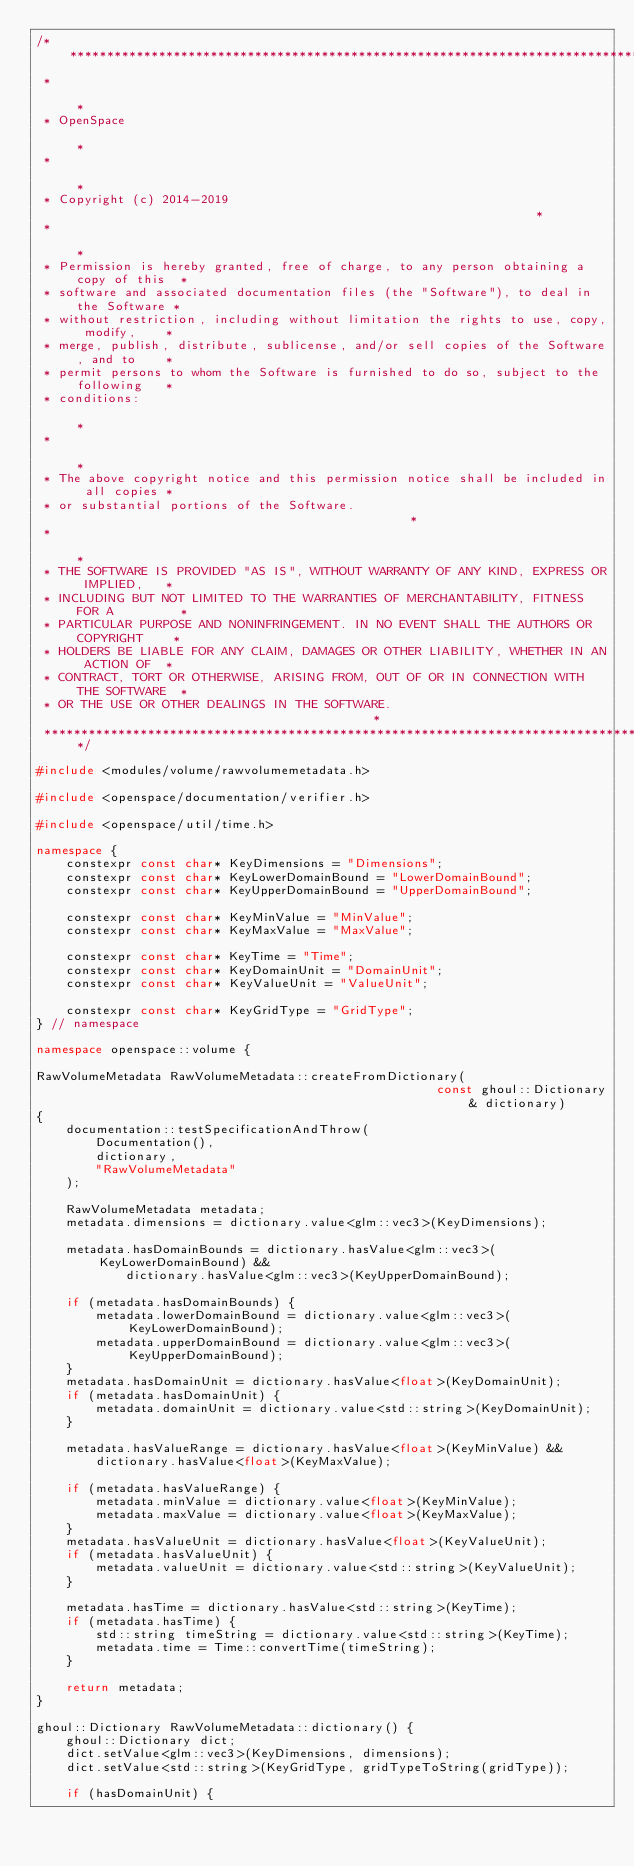Convert code to text. <code><loc_0><loc_0><loc_500><loc_500><_C++_>/*****************************************************************************************
 *                                                                                       *
 * OpenSpace                                                                             *
 *                                                                                       *
 * Copyright (c) 2014-2019                                                               *
 *                                                                                       *
 * Permission is hereby granted, free of charge, to any person obtaining a copy of this  *
 * software and associated documentation files (the "Software"), to deal in the Software *
 * without restriction, including without limitation the rights to use, copy, modify,    *
 * merge, publish, distribute, sublicense, and/or sell copies of the Software, and to    *
 * permit persons to whom the Software is furnished to do so, subject to the following   *
 * conditions:                                                                           *
 *                                                                                       *
 * The above copyright notice and this permission notice shall be included in all copies *
 * or substantial portions of the Software.                                              *
 *                                                                                       *
 * THE SOFTWARE IS PROVIDED "AS IS", WITHOUT WARRANTY OF ANY KIND, EXPRESS OR IMPLIED,   *
 * INCLUDING BUT NOT LIMITED TO THE WARRANTIES OF MERCHANTABILITY, FITNESS FOR A         *
 * PARTICULAR PURPOSE AND NONINFRINGEMENT. IN NO EVENT SHALL THE AUTHORS OR COPYRIGHT    *
 * HOLDERS BE LIABLE FOR ANY CLAIM, DAMAGES OR OTHER LIABILITY, WHETHER IN AN ACTION OF  *
 * CONTRACT, TORT OR OTHERWISE, ARISING FROM, OUT OF OR IN CONNECTION WITH THE SOFTWARE  *
 * OR THE USE OR OTHER DEALINGS IN THE SOFTWARE.                                         *
 ****************************************************************************************/

#include <modules/volume/rawvolumemetadata.h>

#include <openspace/documentation/verifier.h>

#include <openspace/util/time.h>

namespace {
    constexpr const char* KeyDimensions = "Dimensions";
    constexpr const char* KeyLowerDomainBound = "LowerDomainBound";
    constexpr const char* KeyUpperDomainBound = "UpperDomainBound";

    constexpr const char* KeyMinValue = "MinValue";
    constexpr const char* KeyMaxValue = "MaxValue";

    constexpr const char* KeyTime = "Time";
    constexpr const char* KeyDomainUnit = "DomainUnit";
    constexpr const char* KeyValueUnit = "ValueUnit";

    constexpr const char* KeyGridType = "GridType";
} // namespace

namespace openspace::volume {

RawVolumeMetadata RawVolumeMetadata::createFromDictionary(
                                                      const ghoul::Dictionary& dictionary)
{
    documentation::testSpecificationAndThrow(
        Documentation(),
        dictionary,
        "RawVolumeMetadata"
    );

    RawVolumeMetadata metadata;
    metadata.dimensions = dictionary.value<glm::vec3>(KeyDimensions);

    metadata.hasDomainBounds = dictionary.hasValue<glm::vec3>(KeyLowerDomainBound) &&
            dictionary.hasValue<glm::vec3>(KeyUpperDomainBound);

    if (metadata.hasDomainBounds) {
        metadata.lowerDomainBound = dictionary.value<glm::vec3>(KeyLowerDomainBound);
        metadata.upperDomainBound = dictionary.value<glm::vec3>(KeyUpperDomainBound);
    }
    metadata.hasDomainUnit = dictionary.hasValue<float>(KeyDomainUnit);
    if (metadata.hasDomainUnit) {
        metadata.domainUnit = dictionary.value<std::string>(KeyDomainUnit);
    }

    metadata.hasValueRange = dictionary.hasValue<float>(KeyMinValue) &&
        dictionary.hasValue<float>(KeyMaxValue);

    if (metadata.hasValueRange) {
        metadata.minValue = dictionary.value<float>(KeyMinValue);
        metadata.maxValue = dictionary.value<float>(KeyMaxValue);
    }
    metadata.hasValueUnit = dictionary.hasValue<float>(KeyValueUnit);
    if (metadata.hasValueUnit) {
        metadata.valueUnit = dictionary.value<std::string>(KeyValueUnit);
    }

    metadata.hasTime = dictionary.hasValue<std::string>(KeyTime);
    if (metadata.hasTime) {
        std::string timeString = dictionary.value<std::string>(KeyTime);
        metadata.time = Time::convertTime(timeString);
    }

    return metadata;
}

ghoul::Dictionary RawVolumeMetadata::dictionary() {
    ghoul::Dictionary dict;
    dict.setValue<glm::vec3>(KeyDimensions, dimensions);
    dict.setValue<std::string>(KeyGridType, gridTypeToString(gridType));

    if (hasDomainUnit) {</code> 